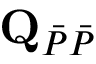Convert formula to latex. <formula><loc_0><loc_0><loc_500><loc_500>Q _ { \ B a r { P } \ B a r { P } }</formula> 